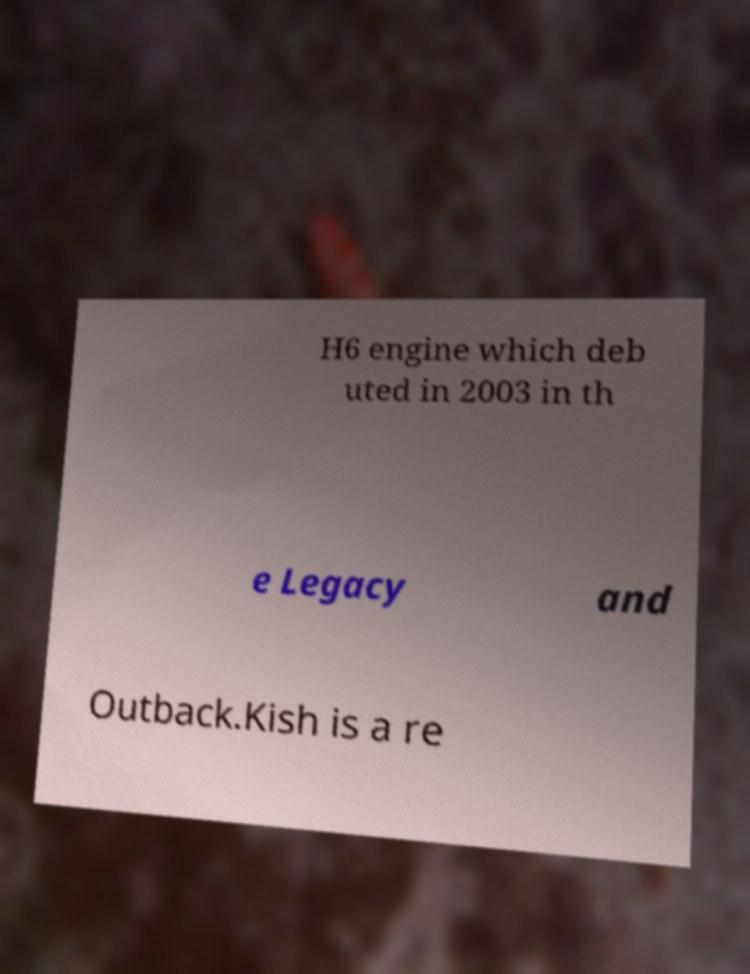Can you accurately transcribe the text from the provided image for me? H6 engine which deb uted in 2003 in th e Legacy and Outback.Kish is a re 